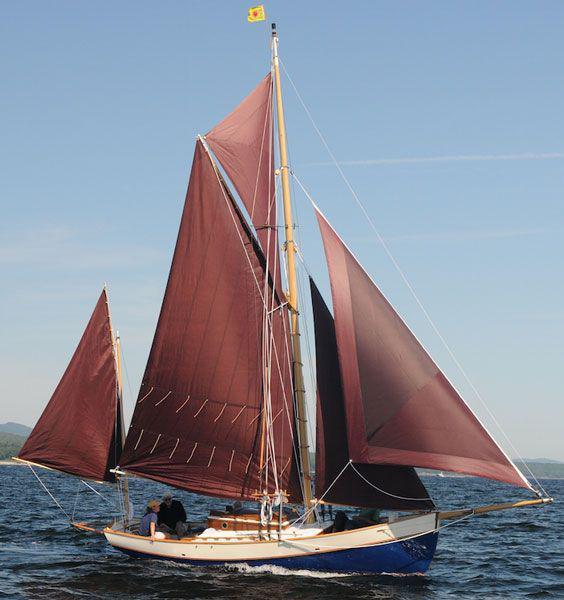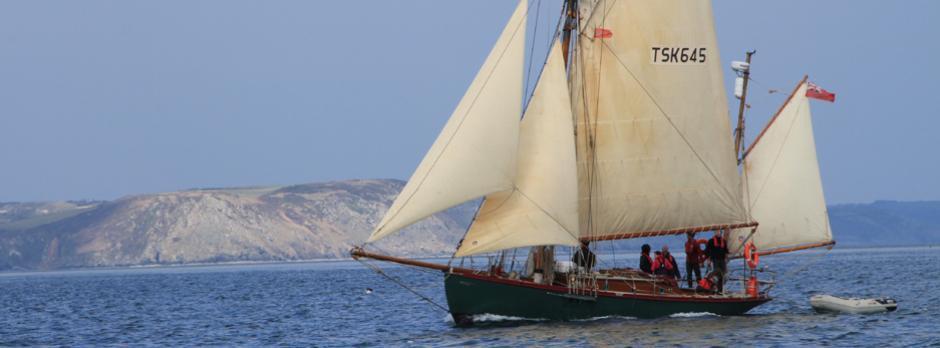The first image is the image on the left, the second image is the image on the right. Evaluate the accuracy of this statement regarding the images: "White sea spray surrounds the boat in one of the images.". Is it true? Answer yes or no. No. 